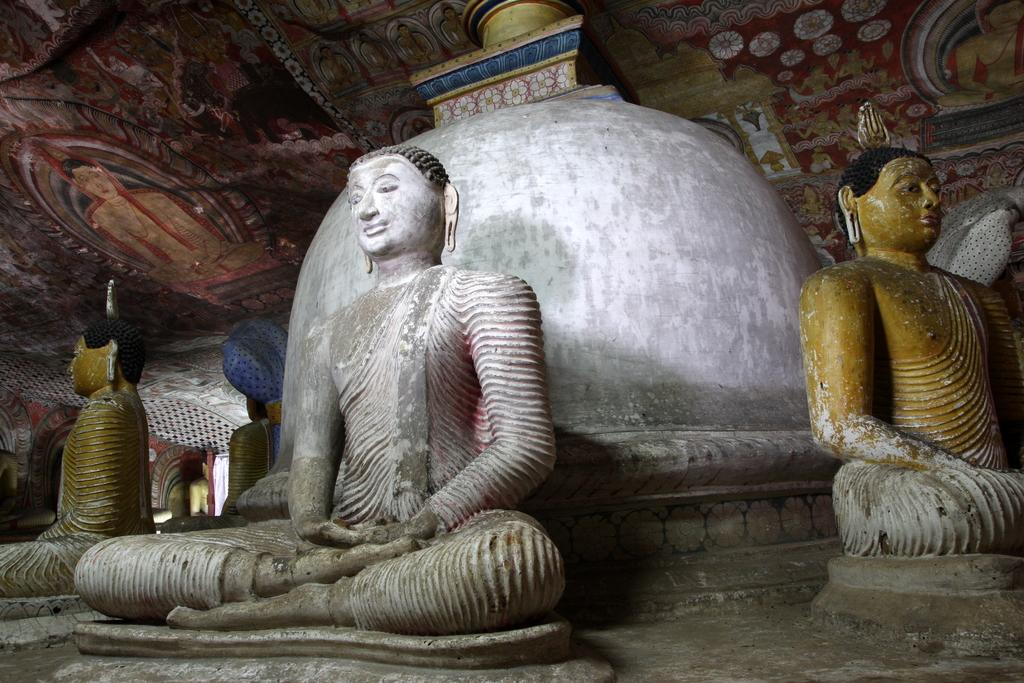What type of objects can be seen on the roof in the image? There are statues and paintings on the roof in the image. Can you describe the statues in the image? The statues are located on the roof, but their specific details are not mentioned in the provided facts. What else is present on the roof besides the statues? The paintings are also present on the roof in the image. What type of writing can be seen on the paintings in the image? There is no mention of writing on the paintings in the provided facts, so it cannot be determined from the image. 